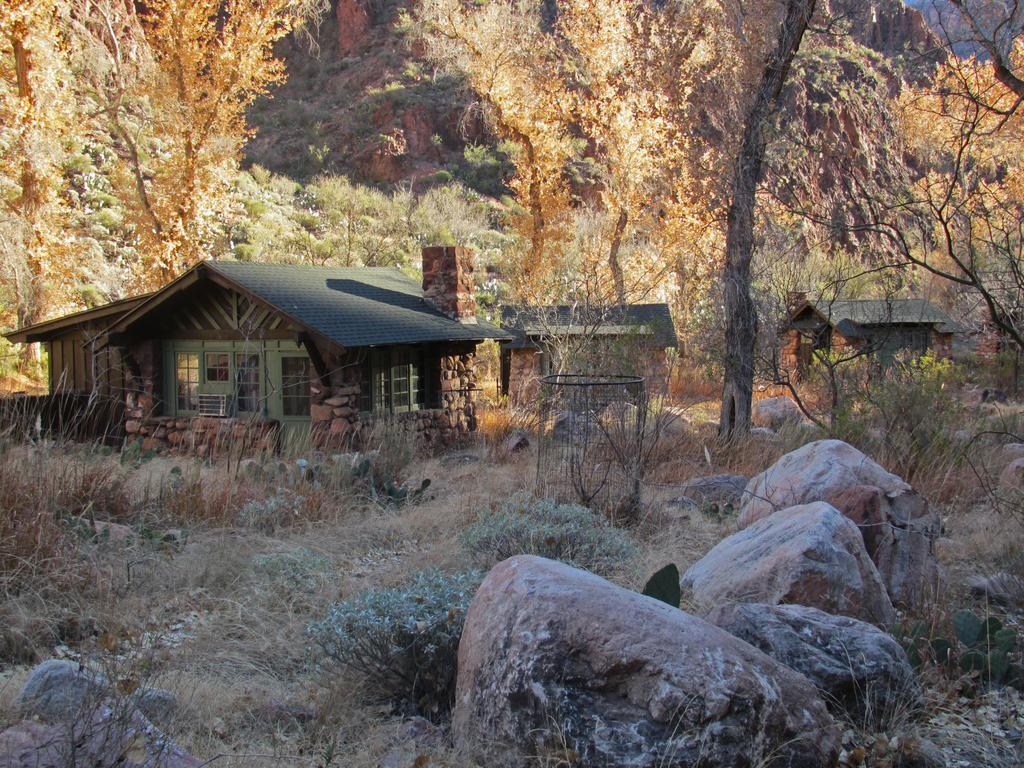What type of structures can be seen in the image? There are houses in the image. What other elements are present in the image besides the houses? There are plants and rocks visible in the image. What can be seen in the background of the image? There are trees in the background of the image. What type of soap is being used to clean the rocks in the image? There is no soap or cleaning activity present in the image; it only features houses, plants, rocks, and trees. 